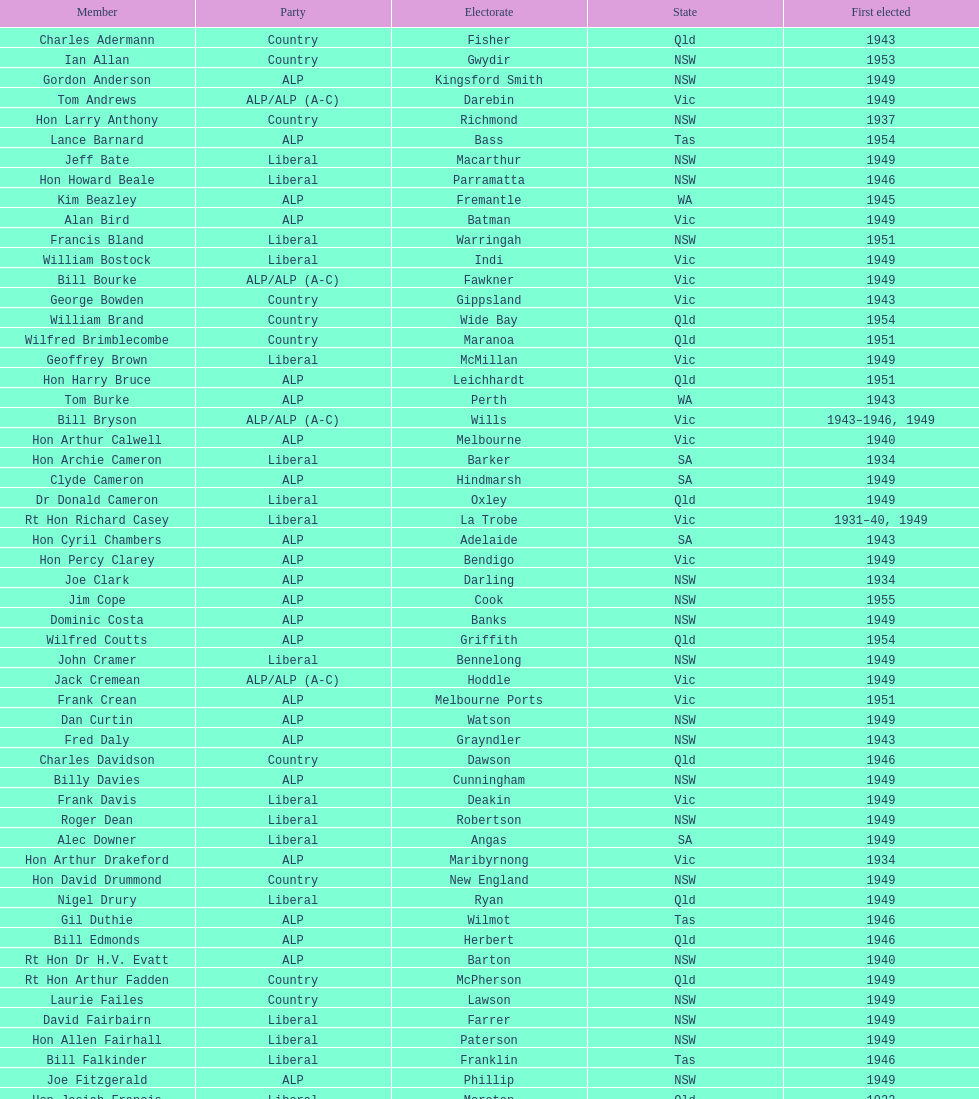Which party had the lowest election result? Country. 